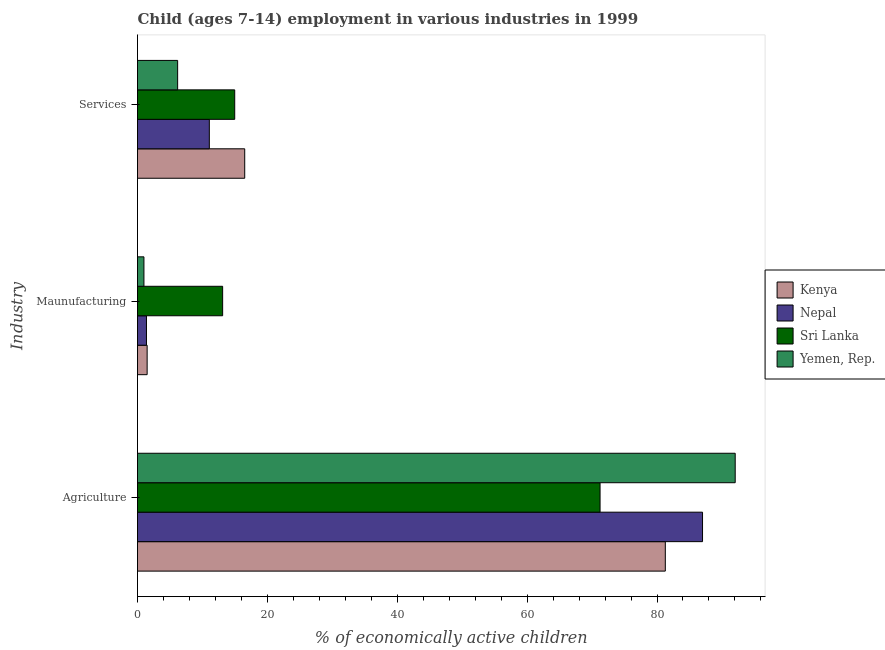How many different coloured bars are there?
Make the answer very short. 4. Are the number of bars per tick equal to the number of legend labels?
Provide a short and direct response. Yes. How many bars are there on the 1st tick from the top?
Your answer should be compact. 4. How many bars are there on the 1st tick from the bottom?
Your answer should be very brief. 4. What is the label of the 3rd group of bars from the top?
Your answer should be very brief. Agriculture. What is the percentage of economically active children in services in Nepal?
Provide a short and direct response. 11.06. Across all countries, what is the maximum percentage of economically active children in services?
Your response must be concise. 16.51. Across all countries, what is the minimum percentage of economically active children in agriculture?
Make the answer very short. 71.23. In which country was the percentage of economically active children in agriculture maximum?
Provide a short and direct response. Yemen, Rep. In which country was the percentage of economically active children in manufacturing minimum?
Ensure brevity in your answer.  Yemen, Rep. What is the total percentage of economically active children in agriculture in the graph?
Offer a terse response. 331.56. What is the difference between the percentage of economically active children in services in Kenya and that in Sri Lanka?
Ensure brevity in your answer.  1.54. What is the difference between the percentage of economically active children in agriculture in Sri Lanka and the percentage of economically active children in manufacturing in Kenya?
Ensure brevity in your answer.  69.75. What is the average percentage of economically active children in agriculture per country?
Make the answer very short. 82.89. What is the difference between the percentage of economically active children in manufacturing and percentage of economically active children in services in Kenya?
Your answer should be very brief. -15.03. In how many countries, is the percentage of economically active children in manufacturing greater than 44 %?
Offer a terse response. 0. What is the ratio of the percentage of economically active children in services in Sri Lanka to that in Yemen, Rep.?
Your response must be concise. 2.42. Is the percentage of economically active children in manufacturing in Nepal less than that in Yemen, Rep.?
Ensure brevity in your answer.  No. Is the difference between the percentage of economically active children in agriculture in Sri Lanka and Kenya greater than the difference between the percentage of economically active children in manufacturing in Sri Lanka and Kenya?
Make the answer very short. No. What is the difference between the highest and the second highest percentage of economically active children in services?
Your response must be concise. 1.54. What is the difference between the highest and the lowest percentage of economically active children in agriculture?
Ensure brevity in your answer.  20.81. In how many countries, is the percentage of economically active children in agriculture greater than the average percentage of economically active children in agriculture taken over all countries?
Ensure brevity in your answer.  2. What does the 2nd bar from the top in Agriculture represents?
Offer a very short reply. Sri Lanka. What does the 4th bar from the bottom in Maunufacturing represents?
Make the answer very short. Yemen, Rep. Is it the case that in every country, the sum of the percentage of economically active children in agriculture and percentage of economically active children in manufacturing is greater than the percentage of economically active children in services?
Make the answer very short. Yes. Are all the bars in the graph horizontal?
Make the answer very short. Yes. Are the values on the major ticks of X-axis written in scientific E-notation?
Ensure brevity in your answer.  No. What is the title of the graph?
Offer a very short reply. Child (ages 7-14) employment in various industries in 1999. What is the label or title of the X-axis?
Provide a short and direct response. % of economically active children. What is the label or title of the Y-axis?
Make the answer very short. Industry. What is the % of economically active children in Kenya in Agriculture?
Provide a short and direct response. 81.28. What is the % of economically active children in Nepal in Agriculture?
Ensure brevity in your answer.  87.01. What is the % of economically active children in Sri Lanka in Agriculture?
Make the answer very short. 71.23. What is the % of economically active children in Yemen, Rep. in Agriculture?
Ensure brevity in your answer.  92.04. What is the % of economically active children of Kenya in Maunufacturing?
Your answer should be very brief. 1.48. What is the % of economically active children of Nepal in Maunufacturing?
Provide a succinct answer. 1.38. What is the % of economically active children in Sri Lanka in Maunufacturing?
Your answer should be compact. 13.11. What is the % of economically active children in Yemen, Rep. in Maunufacturing?
Provide a succinct answer. 0.99. What is the % of economically active children in Kenya in Services?
Keep it short and to the point. 16.51. What is the % of economically active children in Nepal in Services?
Ensure brevity in your answer.  11.06. What is the % of economically active children in Sri Lanka in Services?
Provide a succinct answer. 14.97. What is the % of economically active children in Yemen, Rep. in Services?
Offer a terse response. 6.18. Across all Industry, what is the maximum % of economically active children in Kenya?
Give a very brief answer. 81.28. Across all Industry, what is the maximum % of economically active children of Nepal?
Ensure brevity in your answer.  87.01. Across all Industry, what is the maximum % of economically active children of Sri Lanka?
Provide a short and direct response. 71.23. Across all Industry, what is the maximum % of economically active children in Yemen, Rep.?
Offer a very short reply. 92.04. Across all Industry, what is the minimum % of economically active children in Kenya?
Your response must be concise. 1.48. Across all Industry, what is the minimum % of economically active children of Nepal?
Your answer should be very brief. 1.38. Across all Industry, what is the minimum % of economically active children of Sri Lanka?
Offer a very short reply. 13.11. What is the total % of economically active children in Kenya in the graph?
Keep it short and to the point. 99.27. What is the total % of economically active children in Nepal in the graph?
Keep it short and to the point. 99.45. What is the total % of economically active children in Sri Lanka in the graph?
Offer a terse response. 99.31. What is the total % of economically active children in Yemen, Rep. in the graph?
Keep it short and to the point. 99.21. What is the difference between the % of economically active children in Kenya in Agriculture and that in Maunufacturing?
Keep it short and to the point. 79.8. What is the difference between the % of economically active children of Nepal in Agriculture and that in Maunufacturing?
Give a very brief answer. 85.63. What is the difference between the % of economically active children of Sri Lanka in Agriculture and that in Maunufacturing?
Keep it short and to the point. 58.12. What is the difference between the % of economically active children of Yemen, Rep. in Agriculture and that in Maunufacturing?
Provide a succinct answer. 91.05. What is the difference between the % of economically active children in Kenya in Agriculture and that in Services?
Provide a short and direct response. 64.77. What is the difference between the % of economically active children in Nepal in Agriculture and that in Services?
Provide a short and direct response. 75.95. What is the difference between the % of economically active children of Sri Lanka in Agriculture and that in Services?
Give a very brief answer. 56.26. What is the difference between the % of economically active children of Yemen, Rep. in Agriculture and that in Services?
Keep it short and to the point. 85.86. What is the difference between the % of economically active children of Kenya in Maunufacturing and that in Services?
Ensure brevity in your answer.  -15.03. What is the difference between the % of economically active children of Nepal in Maunufacturing and that in Services?
Give a very brief answer. -9.68. What is the difference between the % of economically active children of Sri Lanka in Maunufacturing and that in Services?
Make the answer very short. -1.86. What is the difference between the % of economically active children of Yemen, Rep. in Maunufacturing and that in Services?
Ensure brevity in your answer.  -5.19. What is the difference between the % of economically active children in Kenya in Agriculture and the % of economically active children in Nepal in Maunufacturing?
Make the answer very short. 79.9. What is the difference between the % of economically active children of Kenya in Agriculture and the % of economically active children of Sri Lanka in Maunufacturing?
Offer a very short reply. 68.17. What is the difference between the % of economically active children of Kenya in Agriculture and the % of economically active children of Yemen, Rep. in Maunufacturing?
Offer a terse response. 80.29. What is the difference between the % of economically active children of Nepal in Agriculture and the % of economically active children of Sri Lanka in Maunufacturing?
Provide a succinct answer. 73.9. What is the difference between the % of economically active children of Nepal in Agriculture and the % of economically active children of Yemen, Rep. in Maunufacturing?
Make the answer very short. 86.02. What is the difference between the % of economically active children of Sri Lanka in Agriculture and the % of economically active children of Yemen, Rep. in Maunufacturing?
Offer a very short reply. 70.24. What is the difference between the % of economically active children in Kenya in Agriculture and the % of economically active children in Nepal in Services?
Keep it short and to the point. 70.22. What is the difference between the % of economically active children in Kenya in Agriculture and the % of economically active children in Sri Lanka in Services?
Ensure brevity in your answer.  66.31. What is the difference between the % of economically active children of Kenya in Agriculture and the % of economically active children of Yemen, Rep. in Services?
Your response must be concise. 75.1. What is the difference between the % of economically active children of Nepal in Agriculture and the % of economically active children of Sri Lanka in Services?
Ensure brevity in your answer.  72.04. What is the difference between the % of economically active children in Nepal in Agriculture and the % of economically active children in Yemen, Rep. in Services?
Offer a terse response. 80.83. What is the difference between the % of economically active children in Sri Lanka in Agriculture and the % of economically active children in Yemen, Rep. in Services?
Your answer should be compact. 65.05. What is the difference between the % of economically active children in Kenya in Maunufacturing and the % of economically active children in Nepal in Services?
Provide a succinct answer. -9.58. What is the difference between the % of economically active children in Kenya in Maunufacturing and the % of economically active children in Sri Lanka in Services?
Ensure brevity in your answer.  -13.49. What is the difference between the % of economically active children in Kenya in Maunufacturing and the % of economically active children in Yemen, Rep. in Services?
Give a very brief answer. -4.7. What is the difference between the % of economically active children of Nepal in Maunufacturing and the % of economically active children of Sri Lanka in Services?
Provide a succinct answer. -13.59. What is the difference between the % of economically active children in Sri Lanka in Maunufacturing and the % of economically active children in Yemen, Rep. in Services?
Offer a terse response. 6.93. What is the average % of economically active children of Kenya per Industry?
Your response must be concise. 33.09. What is the average % of economically active children in Nepal per Industry?
Your response must be concise. 33.15. What is the average % of economically active children in Sri Lanka per Industry?
Offer a terse response. 33.1. What is the average % of economically active children in Yemen, Rep. per Industry?
Your answer should be compact. 33.07. What is the difference between the % of economically active children of Kenya and % of economically active children of Nepal in Agriculture?
Provide a succinct answer. -5.73. What is the difference between the % of economically active children in Kenya and % of economically active children in Sri Lanka in Agriculture?
Give a very brief answer. 10.05. What is the difference between the % of economically active children of Kenya and % of economically active children of Yemen, Rep. in Agriculture?
Provide a succinct answer. -10.76. What is the difference between the % of economically active children in Nepal and % of economically active children in Sri Lanka in Agriculture?
Provide a short and direct response. 15.78. What is the difference between the % of economically active children in Nepal and % of economically active children in Yemen, Rep. in Agriculture?
Your response must be concise. -5.03. What is the difference between the % of economically active children in Sri Lanka and % of economically active children in Yemen, Rep. in Agriculture?
Your answer should be very brief. -20.81. What is the difference between the % of economically active children of Kenya and % of economically active children of Nepal in Maunufacturing?
Your answer should be very brief. 0.1. What is the difference between the % of economically active children of Kenya and % of economically active children of Sri Lanka in Maunufacturing?
Your answer should be compact. -11.63. What is the difference between the % of economically active children of Kenya and % of economically active children of Yemen, Rep. in Maunufacturing?
Offer a very short reply. 0.49. What is the difference between the % of economically active children of Nepal and % of economically active children of Sri Lanka in Maunufacturing?
Make the answer very short. -11.73. What is the difference between the % of economically active children of Nepal and % of economically active children of Yemen, Rep. in Maunufacturing?
Keep it short and to the point. 0.39. What is the difference between the % of economically active children of Sri Lanka and % of economically active children of Yemen, Rep. in Maunufacturing?
Keep it short and to the point. 12.12. What is the difference between the % of economically active children of Kenya and % of economically active children of Nepal in Services?
Keep it short and to the point. 5.45. What is the difference between the % of economically active children of Kenya and % of economically active children of Sri Lanka in Services?
Your answer should be compact. 1.54. What is the difference between the % of economically active children of Kenya and % of economically active children of Yemen, Rep. in Services?
Make the answer very short. 10.33. What is the difference between the % of economically active children in Nepal and % of economically active children in Sri Lanka in Services?
Your answer should be very brief. -3.91. What is the difference between the % of economically active children in Nepal and % of economically active children in Yemen, Rep. in Services?
Provide a succinct answer. 4.88. What is the difference between the % of economically active children of Sri Lanka and % of economically active children of Yemen, Rep. in Services?
Offer a very short reply. 8.79. What is the ratio of the % of economically active children in Kenya in Agriculture to that in Maunufacturing?
Offer a very short reply. 54.84. What is the ratio of the % of economically active children in Nepal in Agriculture to that in Maunufacturing?
Keep it short and to the point. 63.05. What is the ratio of the % of economically active children of Sri Lanka in Agriculture to that in Maunufacturing?
Keep it short and to the point. 5.43. What is the ratio of the % of economically active children of Yemen, Rep. in Agriculture to that in Maunufacturing?
Provide a succinct answer. 92.97. What is the ratio of the % of economically active children of Kenya in Agriculture to that in Services?
Make the answer very short. 4.92. What is the ratio of the % of economically active children of Nepal in Agriculture to that in Services?
Provide a short and direct response. 7.87. What is the ratio of the % of economically active children of Sri Lanka in Agriculture to that in Services?
Your answer should be very brief. 4.76. What is the ratio of the % of economically active children in Yemen, Rep. in Agriculture to that in Services?
Offer a very short reply. 14.89. What is the ratio of the % of economically active children of Kenya in Maunufacturing to that in Services?
Provide a short and direct response. 0.09. What is the ratio of the % of economically active children in Nepal in Maunufacturing to that in Services?
Offer a very short reply. 0.12. What is the ratio of the % of economically active children in Sri Lanka in Maunufacturing to that in Services?
Your answer should be very brief. 0.88. What is the ratio of the % of economically active children of Yemen, Rep. in Maunufacturing to that in Services?
Provide a short and direct response. 0.16. What is the difference between the highest and the second highest % of economically active children of Kenya?
Offer a terse response. 64.77. What is the difference between the highest and the second highest % of economically active children of Nepal?
Offer a terse response. 75.95. What is the difference between the highest and the second highest % of economically active children of Sri Lanka?
Ensure brevity in your answer.  56.26. What is the difference between the highest and the second highest % of economically active children in Yemen, Rep.?
Provide a short and direct response. 85.86. What is the difference between the highest and the lowest % of economically active children of Kenya?
Your response must be concise. 79.8. What is the difference between the highest and the lowest % of economically active children in Nepal?
Your answer should be compact. 85.63. What is the difference between the highest and the lowest % of economically active children of Sri Lanka?
Make the answer very short. 58.12. What is the difference between the highest and the lowest % of economically active children in Yemen, Rep.?
Keep it short and to the point. 91.05. 